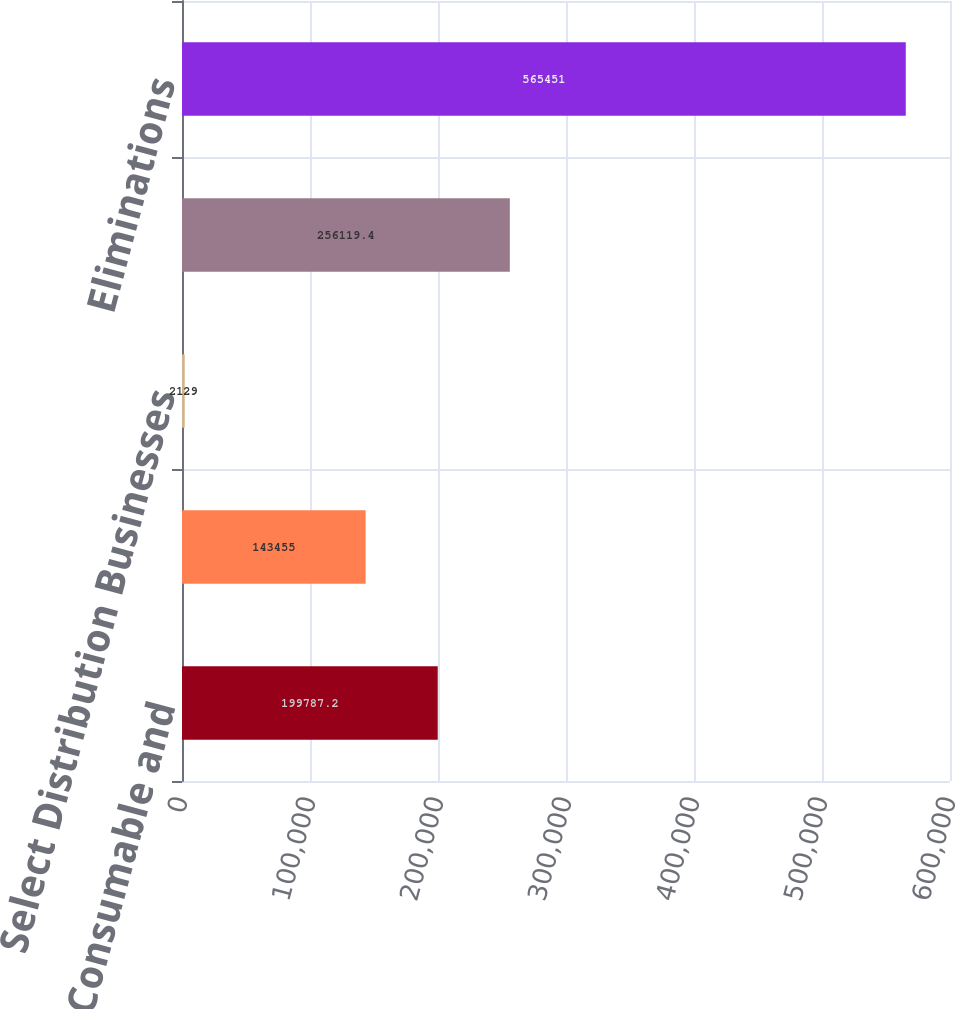<chart> <loc_0><loc_0><loc_500><loc_500><bar_chart><fcel>Dental Consumable and<fcel>Unnamed: 1<fcel>Select Distribution Businesses<fcel>All Other (c)<fcel>Eliminations<nl><fcel>199787<fcel>143455<fcel>2129<fcel>256119<fcel>565451<nl></chart> 